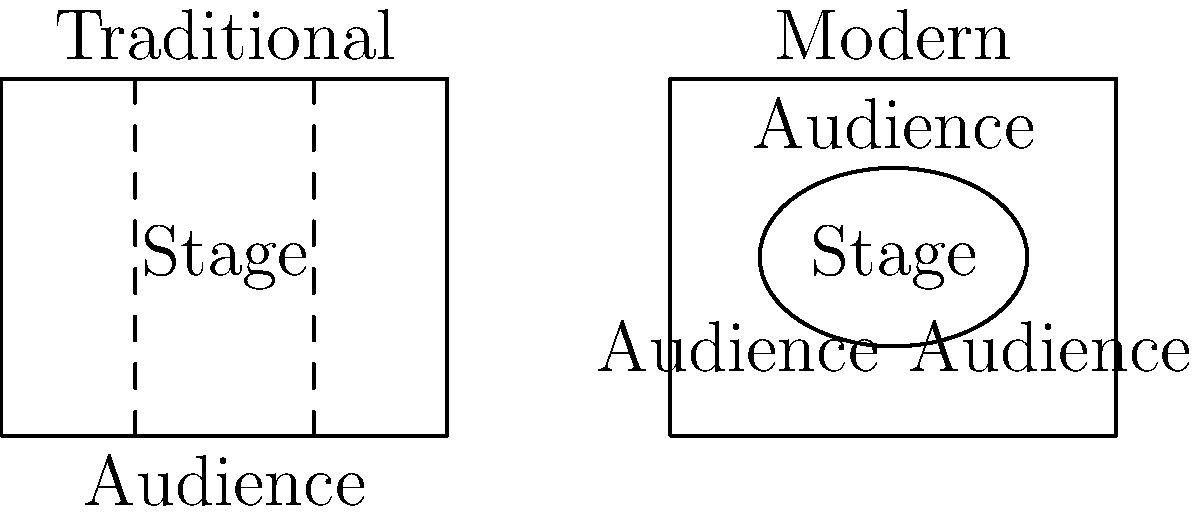Analyze the diagrams depicting traditional and modern stage layouts for Shakespearean plays. How does the modern layout challenge the conventional audience-performer relationship, and what potential consequences might this have on the authenticity and impact of classical performances? To answer this question, let's examine the key differences between the traditional and modern stage layouts:

1. Traditional layout:
   - Rectangular stage with a clear front (facing the audience)
   - Audience positioned only in front of the stage
   - Clear separation between performers and spectators

2. Modern layout:
   - Circular or thrust stage
   - Audience surrounds the stage on multiple sides
   - Reduced distance between performers and spectators

The modern layout challenges the conventional audience-performer relationship in several ways:

1. Proximity: The modern layout brings the audience closer to the action, potentially disrupting the "fourth wall" concept typical in traditional performances.

2. Multiple perspectives: Audiences view the performance from different angles, which may affect the intended visual composition of scenes.

3. Performer awareness: Actors must be conscious of multiple viewing angles, potentially altering their movements and positioning.

4. Set design limitations: The modern layout restricts the use of large, elaborate backdrops and set pieces common in traditional productions.

5. Intimacy vs. spectacle: The closer proximity may enhance intimacy but could diminish the grand spectacle often associated with classical performances.

Consequences on authenticity and impact:

1. Interpretation: The modern layout may lead to reinterpretations of classic scenes, potentially altering their original intent or symbolism.

2. Audience engagement: Increased proximity might enhance emotional connection but could detract from the reverence traditionally associated with Shakespearean performances.

3. Textual emphasis: The stripped-down nature of modern layouts might place greater emphasis on the text and performances, potentially at the expense of visual spectacle.

4. Historical accuracy: The modern layout diverges from the original performance conditions of Shakespearean plays, potentially compromising historical authenticity.

5. Artistic vision: While potentially offering new insights, the modern layout may conflict with the playwright's original staging intentions.
Answer: Modern layout challenges traditional audience-performer dynamics, potentially compromising historical authenticity while offering increased intimacy and new interpretations at the expense of original staging intentions and visual spectacle. 